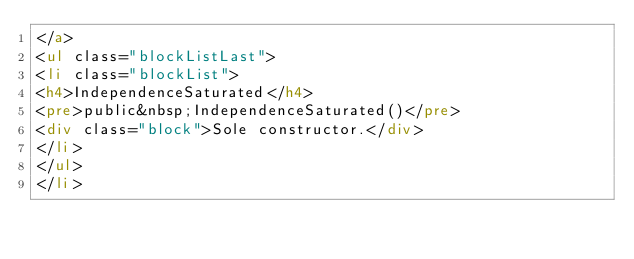Convert code to text. <code><loc_0><loc_0><loc_500><loc_500><_HTML_></a>
<ul class="blockListLast">
<li class="blockList">
<h4>IndependenceSaturated</h4>
<pre>public&nbsp;IndependenceSaturated()</pre>
<div class="block">Sole constructor.</div>
</li>
</ul>
</li></code> 